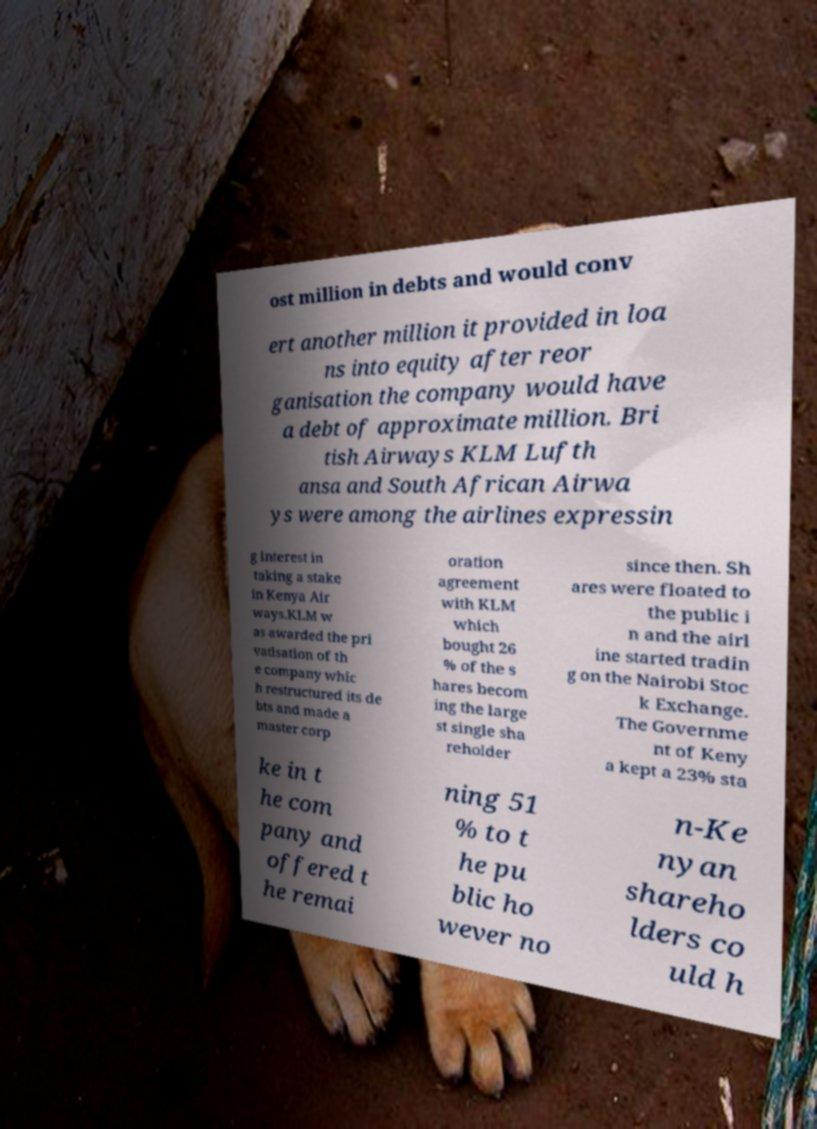I need the written content from this picture converted into text. Can you do that? ost million in debts and would conv ert another million it provided in loa ns into equity after reor ganisation the company would have a debt of approximate million. Bri tish Airways KLM Lufth ansa and South African Airwa ys were among the airlines expressin g interest in taking a stake in Kenya Air ways.KLM w as awarded the pri vatisation of th e company whic h restructured its de bts and made a master corp oration agreement with KLM which bought 26 % of the s hares becom ing the large st single sha reholder since then. Sh ares were floated to the public i n and the airl ine started tradin g on the Nairobi Stoc k Exchange. The Governme nt of Keny a kept a 23% sta ke in t he com pany and offered t he remai ning 51 % to t he pu blic ho wever no n-Ke nyan shareho lders co uld h 